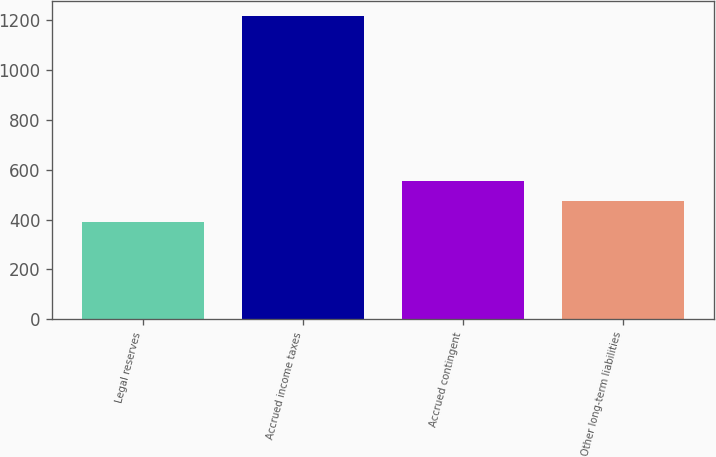<chart> <loc_0><loc_0><loc_500><loc_500><bar_chart><fcel>Legal reserves<fcel>Accrued income taxes<fcel>Accrued contingent<fcel>Other long-term liabilities<nl><fcel>391<fcel>1215<fcel>555.8<fcel>473.4<nl></chart> 